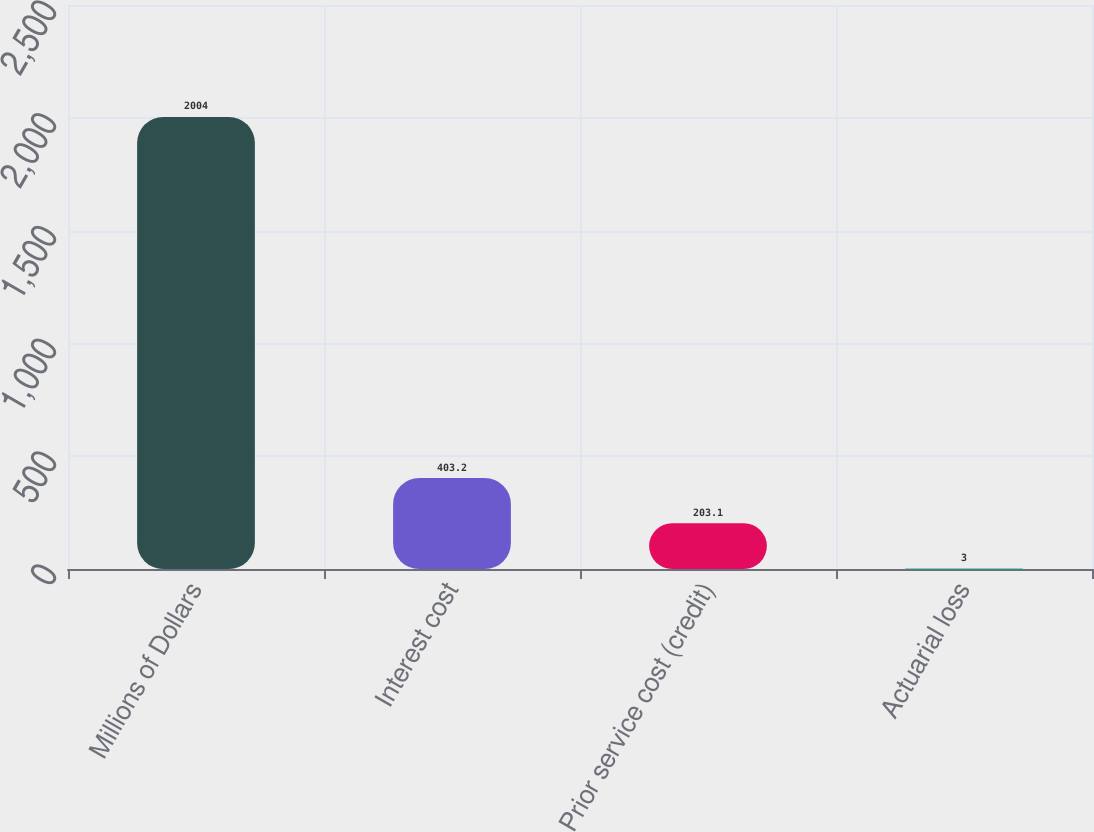Convert chart to OTSL. <chart><loc_0><loc_0><loc_500><loc_500><bar_chart><fcel>Millions of Dollars<fcel>Interest cost<fcel>Prior service cost (credit)<fcel>Actuarial loss<nl><fcel>2004<fcel>403.2<fcel>203.1<fcel>3<nl></chart> 